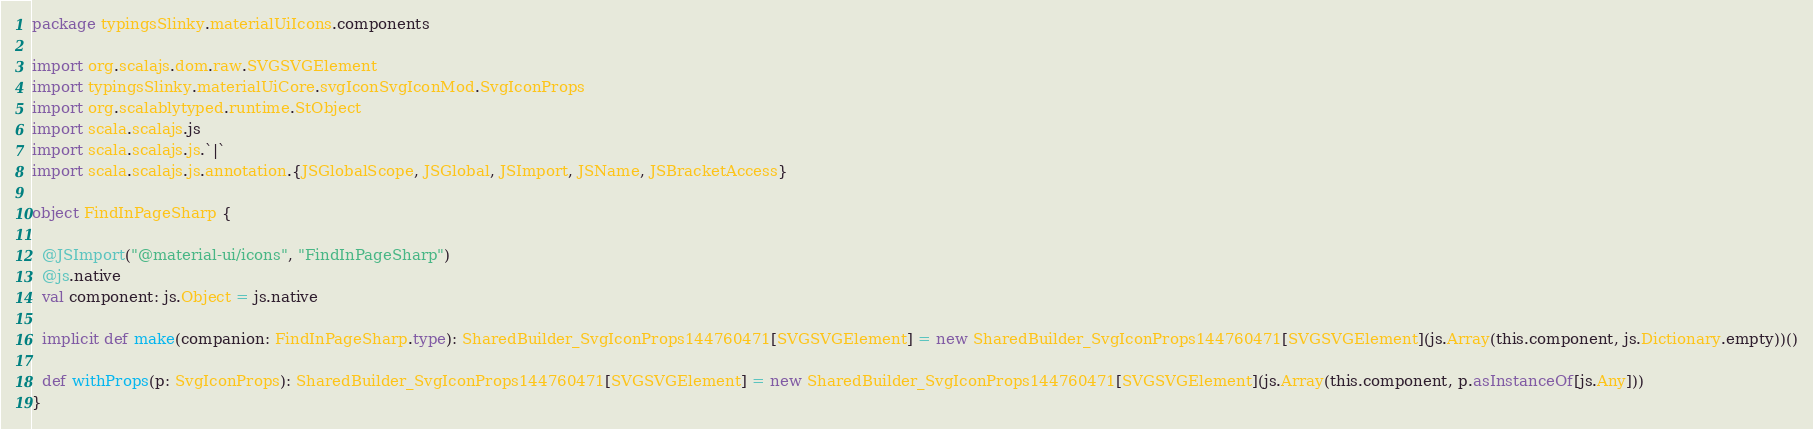Convert code to text. <code><loc_0><loc_0><loc_500><loc_500><_Scala_>package typingsSlinky.materialUiIcons.components

import org.scalajs.dom.raw.SVGSVGElement
import typingsSlinky.materialUiCore.svgIconSvgIconMod.SvgIconProps
import org.scalablytyped.runtime.StObject
import scala.scalajs.js
import scala.scalajs.js.`|`
import scala.scalajs.js.annotation.{JSGlobalScope, JSGlobal, JSImport, JSName, JSBracketAccess}

object FindInPageSharp {
  
  @JSImport("@material-ui/icons", "FindInPageSharp")
  @js.native
  val component: js.Object = js.native
  
  implicit def make(companion: FindInPageSharp.type): SharedBuilder_SvgIconProps144760471[SVGSVGElement] = new SharedBuilder_SvgIconProps144760471[SVGSVGElement](js.Array(this.component, js.Dictionary.empty))()
  
  def withProps(p: SvgIconProps): SharedBuilder_SvgIconProps144760471[SVGSVGElement] = new SharedBuilder_SvgIconProps144760471[SVGSVGElement](js.Array(this.component, p.asInstanceOf[js.Any]))
}
</code> 